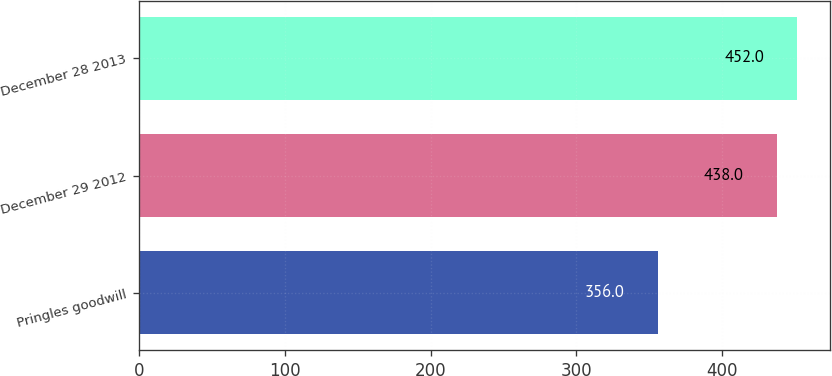Convert chart. <chart><loc_0><loc_0><loc_500><loc_500><bar_chart><fcel>Pringles goodwill<fcel>December 29 2012<fcel>December 28 2013<nl><fcel>356<fcel>438<fcel>452<nl></chart> 